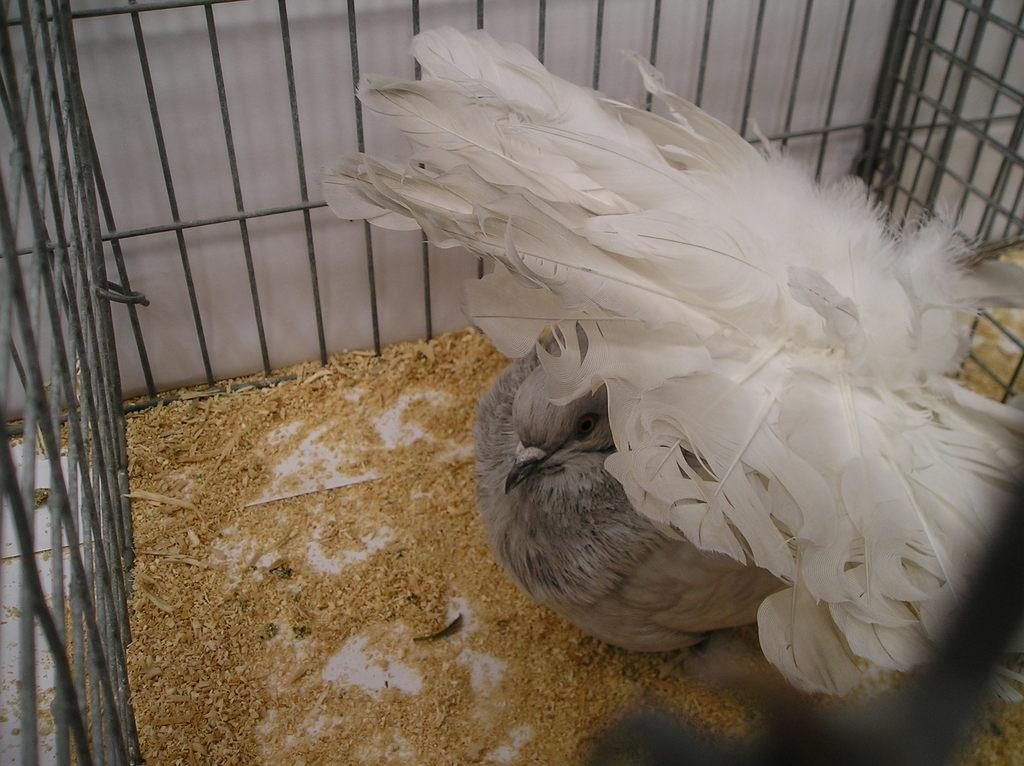What type of animal is in the image? There is a bird in the image. Where is the bird located? The bird is in a cage. What color are the bird's feathers? The bird has white feathers. What is at the bottom of the image? There is wood sawdust at the bottom of the image. What type of pest is the cook trying to eliminate in the image? There is no cook or pest present in the image; it features a bird in a cage with wood sawdust at the bottom. 